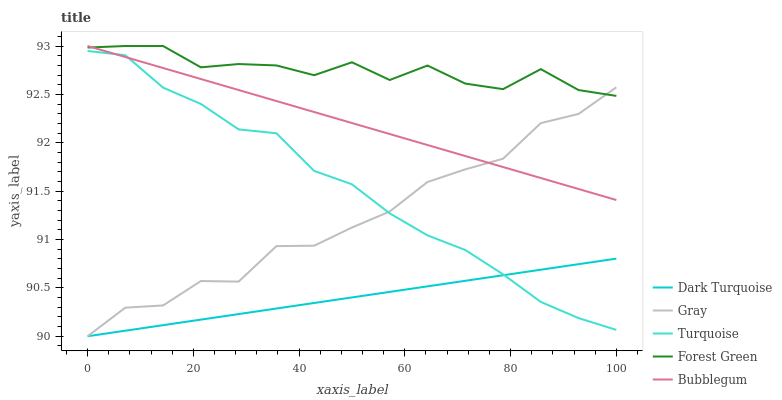Does Dark Turquoise have the minimum area under the curve?
Answer yes or no. Yes. Does Forest Green have the maximum area under the curve?
Answer yes or no. Yes. Does Turquoise have the minimum area under the curve?
Answer yes or no. No. Does Turquoise have the maximum area under the curve?
Answer yes or no. No. Is Dark Turquoise the smoothest?
Answer yes or no. Yes. Is Forest Green the roughest?
Answer yes or no. Yes. Is Turquoise the smoothest?
Answer yes or no. No. Is Turquoise the roughest?
Answer yes or no. No. Does Dark Turquoise have the lowest value?
Answer yes or no. Yes. Does Turquoise have the lowest value?
Answer yes or no. No. Does Bubblegum have the highest value?
Answer yes or no. Yes. Does Turquoise have the highest value?
Answer yes or no. No. Is Dark Turquoise less than Forest Green?
Answer yes or no. Yes. Is Forest Green greater than Dark Turquoise?
Answer yes or no. Yes. Does Turquoise intersect Bubblegum?
Answer yes or no. Yes. Is Turquoise less than Bubblegum?
Answer yes or no. No. Is Turquoise greater than Bubblegum?
Answer yes or no. No. Does Dark Turquoise intersect Forest Green?
Answer yes or no. No. 